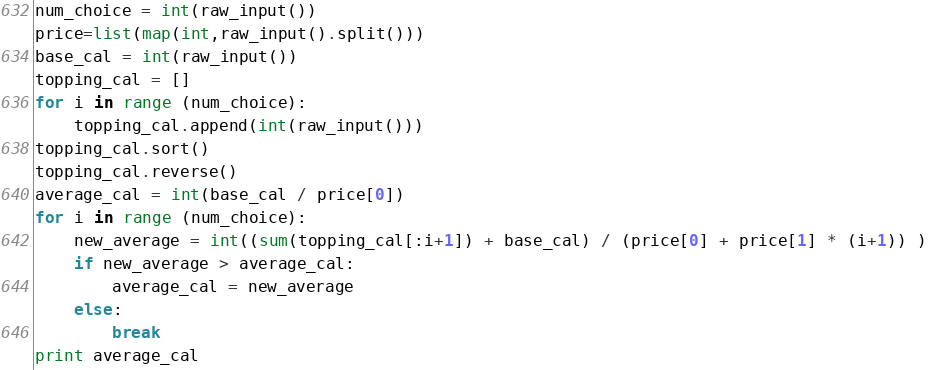<code> <loc_0><loc_0><loc_500><loc_500><_Python_>num_choice = int(raw_input())
price=list(map(int,raw_input().split()))
base_cal = int(raw_input())
topping_cal = []
for i in range (num_choice):
	topping_cal.append(int(raw_input()))
topping_cal.sort()
topping_cal.reverse()
average_cal = int(base_cal / price[0])
for i in range (num_choice):
	new_average = int((sum(topping_cal[:i+1]) + base_cal) / (price[0] + price[1] * (i+1)) )
	if new_average > average_cal:
		average_cal = new_average
	else:
		break
print average_cal</code> 